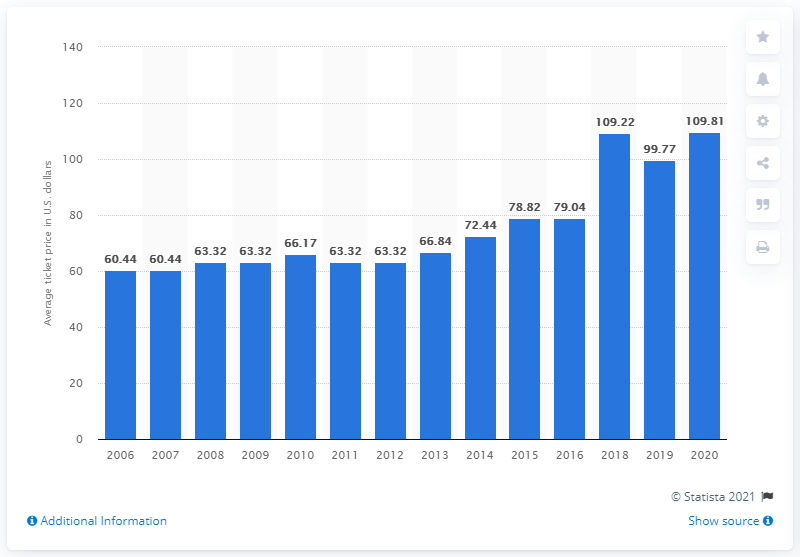Mention a couple of crucial points in this snapshot. The average ticket price for Carolina Panthers games in 2020 was $109.81. 